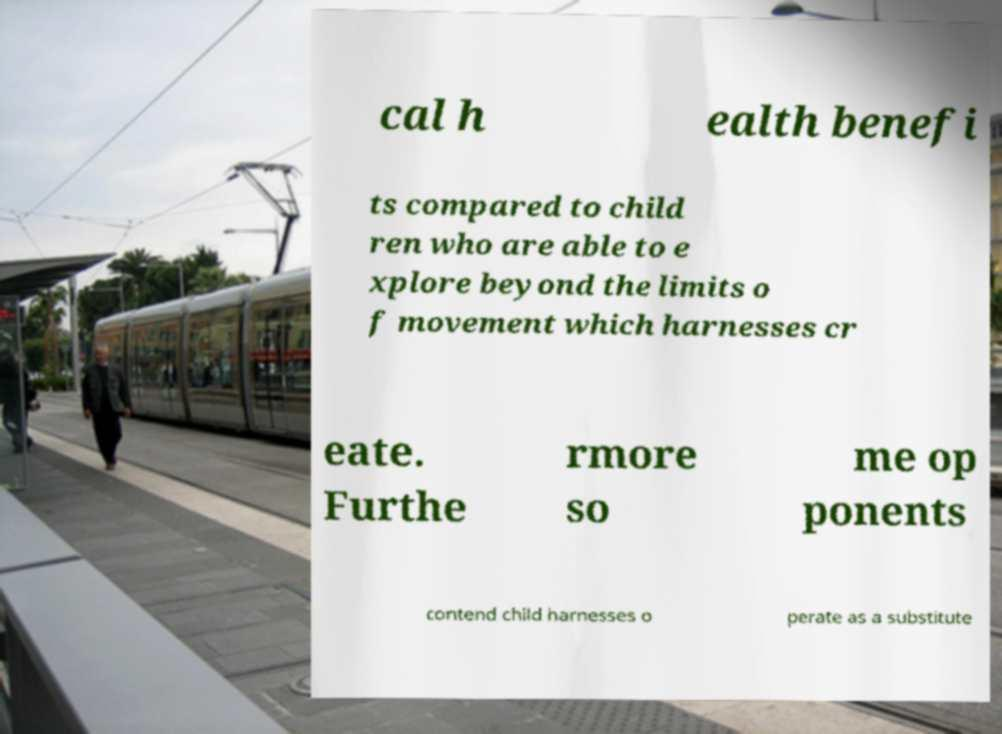What messages or text are displayed in this image? I need them in a readable, typed format. cal h ealth benefi ts compared to child ren who are able to e xplore beyond the limits o f movement which harnesses cr eate. Furthe rmore so me op ponents contend child harnesses o perate as a substitute 